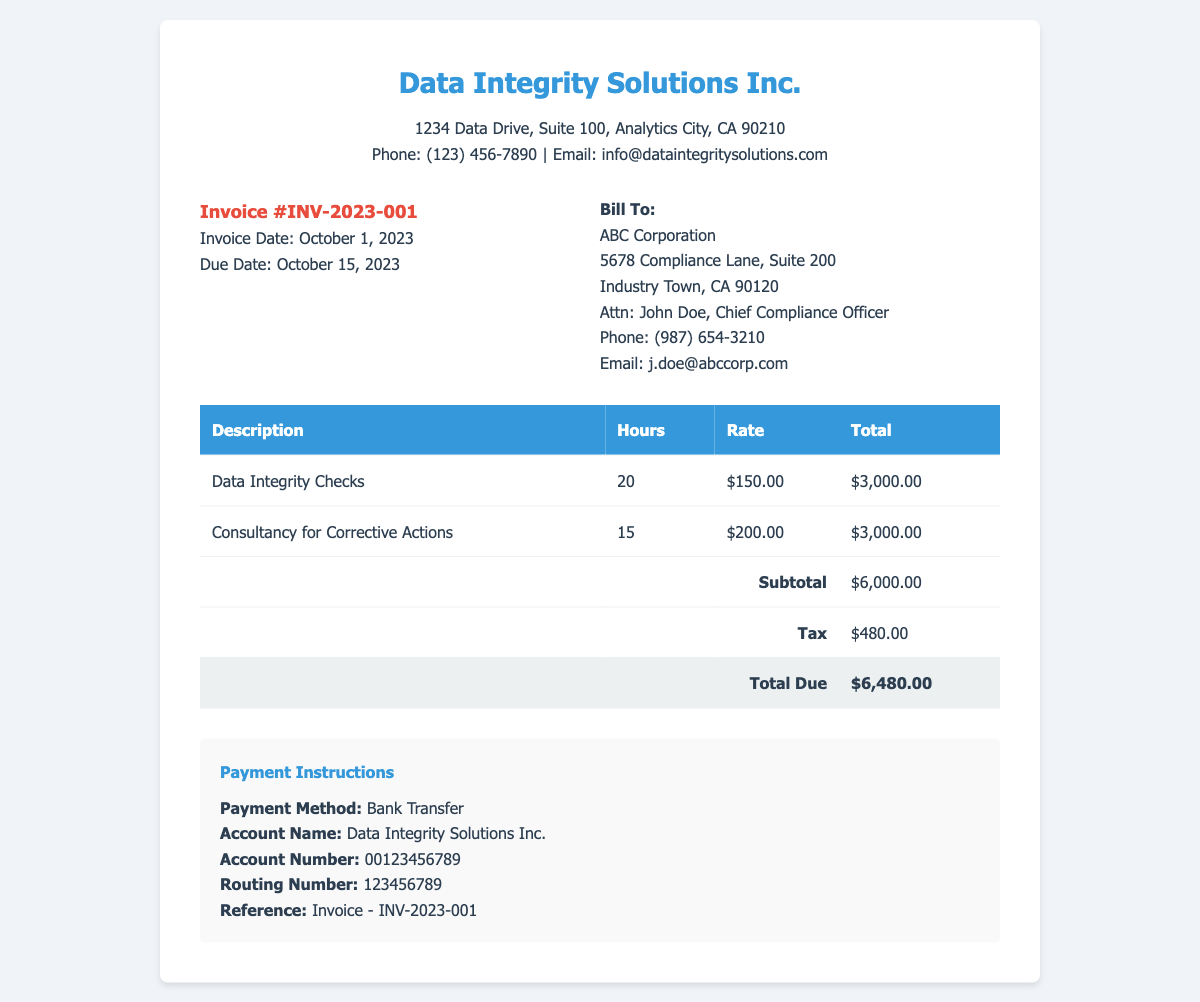What is the invoice number? The invoice number is labeled clearly at the top of the document as "Invoice #INV-2023-001".
Answer: INV-2023-001 Who is the billing recipient? The billing recipient is mentioned in the "Bill To" section of the document, which lists the name of the company and its address.
Answer: ABC Corporation What is the total amount due? The total amount due is stated in the document, specifically highlighted in the total row at the bottom of the table.
Answer: $6,480.00 How many hours were spent on data integrity checks? The hours for data integrity checks are specified in the table under the "Hours" column.
Answer: 20 What is the tax amount charged? The tax amount is presented in the table, clearly labeled under the "Tax" row.
Answer: $480.00 What was the hourly rate for consultancy for corrective actions? The hourly rate is indicated in the table next to the consultancy description.
Answer: $200.00 When is the payment due? The payment due date is provided in the invoice details section of the document.
Answer: October 15, 2023 What payment method is specified? The section regarding payment instructions clearly states the payment method that should be used.
Answer: Bank Transfer How many hours were charged for consultancy hours? The hours charged for consultancy are mentioned in the detailed table in the corresponding row for consultancy.
Answer: 15 